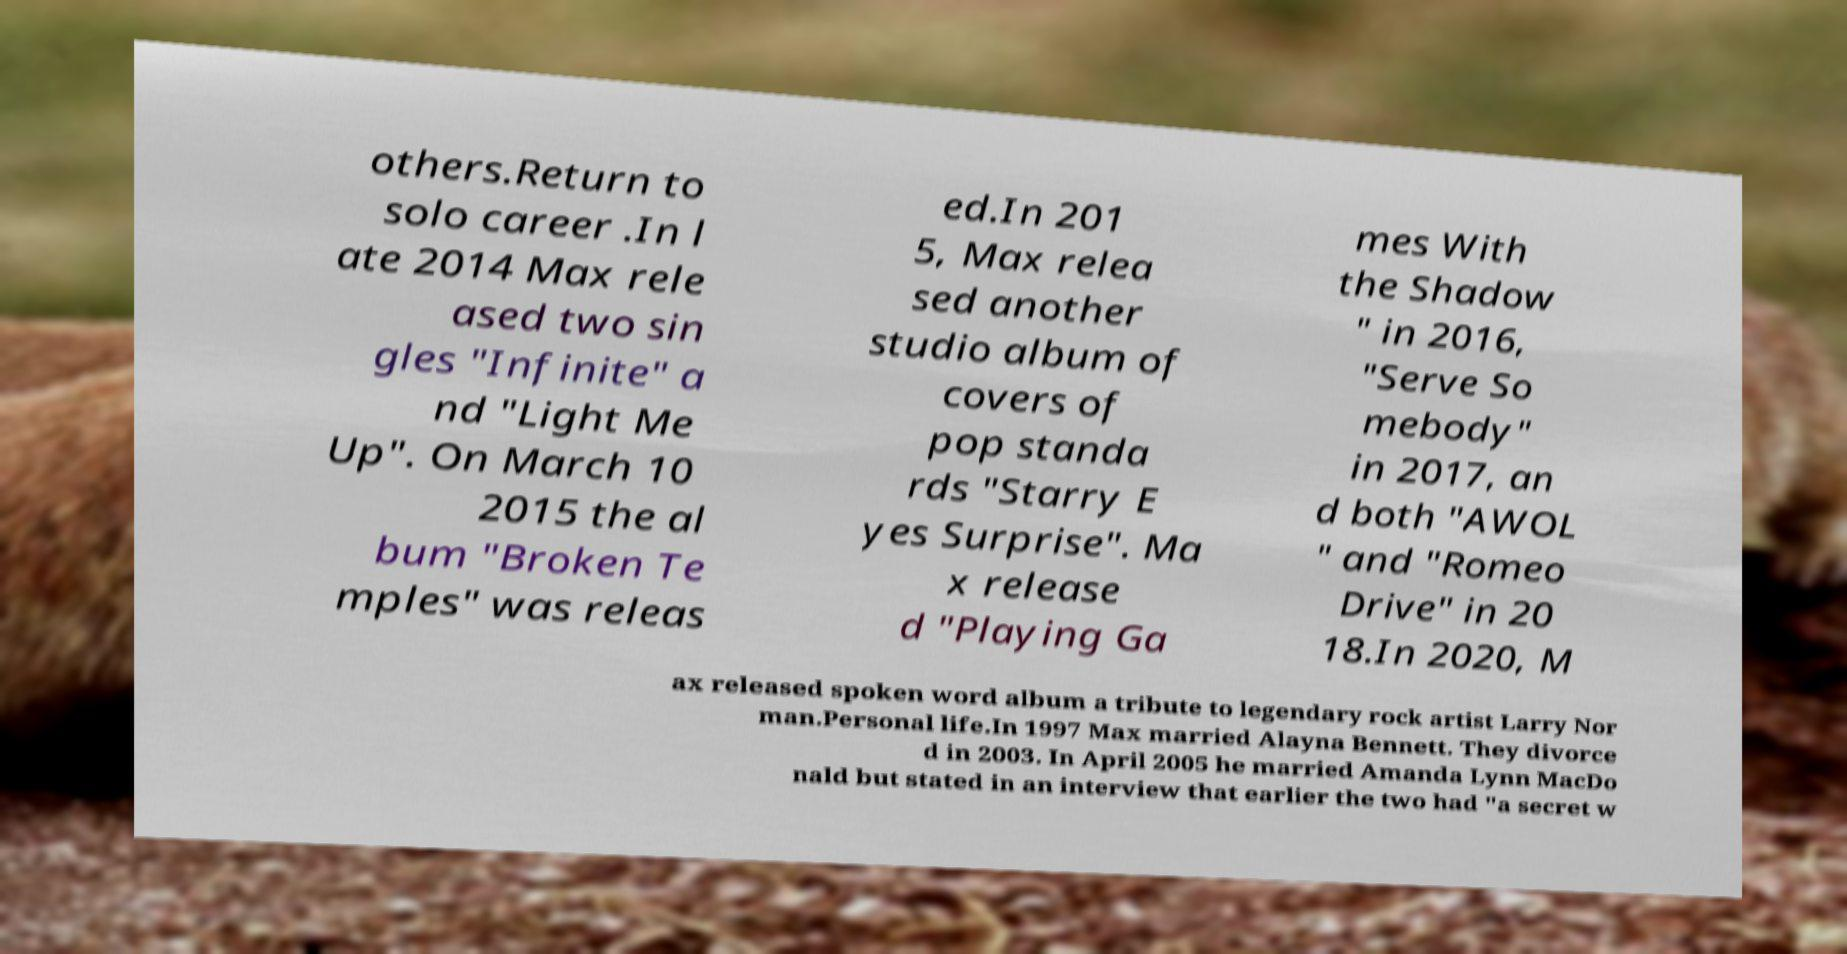There's text embedded in this image that I need extracted. Can you transcribe it verbatim? others.Return to solo career .In l ate 2014 Max rele ased two sin gles "Infinite" a nd "Light Me Up". On March 10 2015 the al bum "Broken Te mples" was releas ed.In 201 5, Max relea sed another studio album of covers of pop standa rds "Starry E yes Surprise". Ma x release d "Playing Ga mes With the Shadow " in 2016, "Serve So mebody" in 2017, an d both "AWOL " and "Romeo Drive" in 20 18.In 2020, M ax released spoken word album a tribute to legendary rock artist Larry Nor man.Personal life.In 1997 Max married Alayna Bennett. They divorce d in 2003. In April 2005 he married Amanda Lynn MacDo nald but stated in an interview that earlier the two had "a secret w 